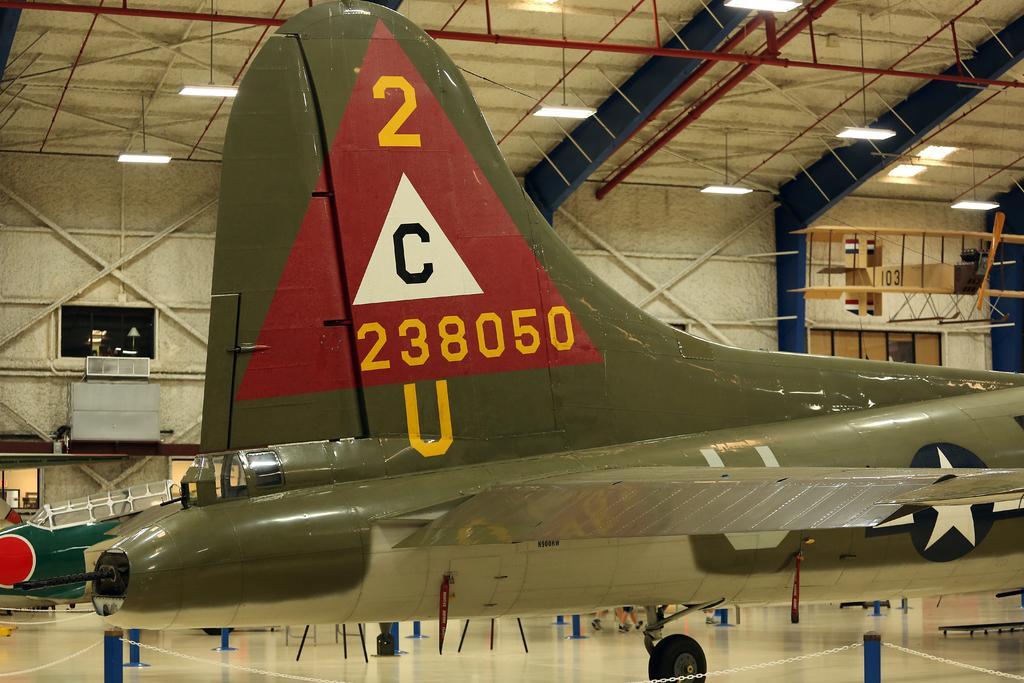<image>
Present a compact description of the photo's key features. Back end of an airplane that says 2 C 238050 U 